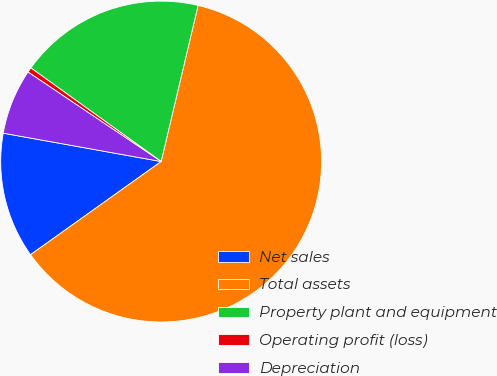<chart> <loc_0><loc_0><loc_500><loc_500><pie_chart><fcel>Net sales<fcel>Total assets<fcel>Property plant and equipment<fcel>Operating profit (loss)<fcel>Depreciation<nl><fcel>12.69%<fcel>61.44%<fcel>18.78%<fcel>0.5%<fcel>6.59%<nl></chart> 